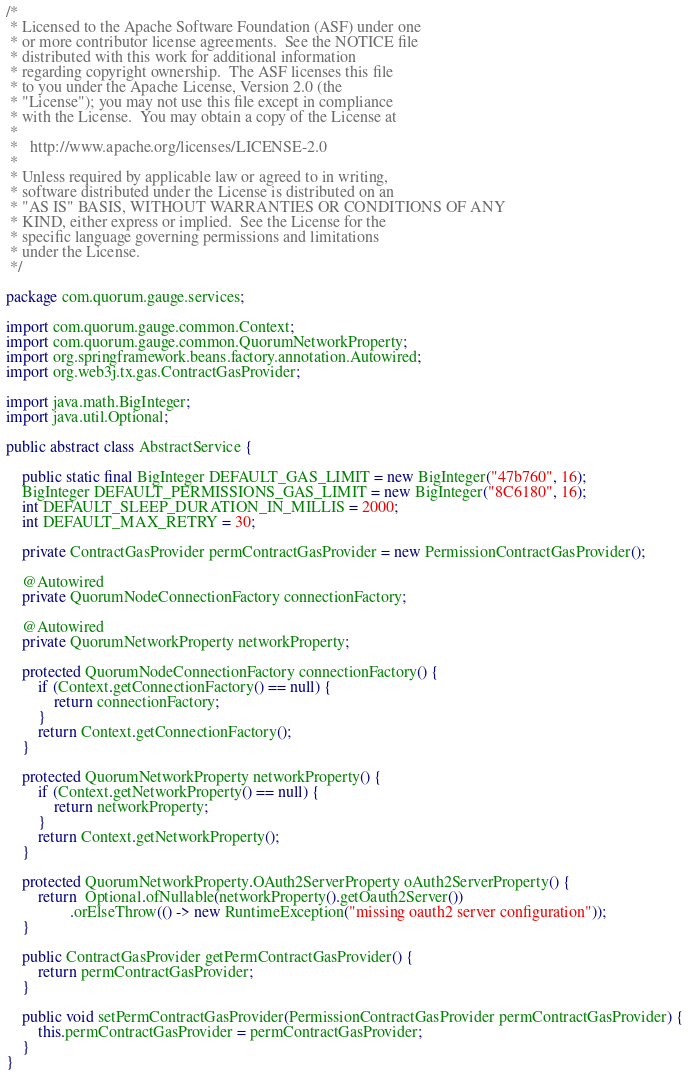<code> <loc_0><loc_0><loc_500><loc_500><_Java_>/*
 * Licensed to the Apache Software Foundation (ASF) under one
 * or more contributor license agreements.  See the NOTICE file
 * distributed with this work for additional information
 * regarding copyright ownership.  The ASF licenses this file
 * to you under the Apache License, Version 2.0 (the
 * "License"); you may not use this file except in compliance
 * with the License.  You may obtain a copy of the License at
 *
 *   http://www.apache.org/licenses/LICENSE-2.0
 *
 * Unless required by applicable law or agreed to in writing,
 * software distributed under the License is distributed on an
 * "AS IS" BASIS, WITHOUT WARRANTIES OR CONDITIONS OF ANY
 * KIND, either express or implied.  See the License for the
 * specific language governing permissions and limitations
 * under the License.
 */

package com.quorum.gauge.services;

import com.quorum.gauge.common.Context;
import com.quorum.gauge.common.QuorumNetworkProperty;
import org.springframework.beans.factory.annotation.Autowired;
import org.web3j.tx.gas.ContractGasProvider;

import java.math.BigInteger;
import java.util.Optional;

public abstract class AbstractService {

    public static final BigInteger DEFAULT_GAS_LIMIT = new BigInteger("47b760", 16);
    BigInteger DEFAULT_PERMISSIONS_GAS_LIMIT = new BigInteger("8C6180", 16);
    int DEFAULT_SLEEP_DURATION_IN_MILLIS = 2000;
    int DEFAULT_MAX_RETRY = 30;

    private ContractGasProvider permContractGasProvider = new PermissionContractGasProvider();

    @Autowired
    private QuorumNodeConnectionFactory connectionFactory;

    @Autowired
    private QuorumNetworkProperty networkProperty;

    protected QuorumNodeConnectionFactory connectionFactory() {
        if (Context.getConnectionFactory() == null) {
            return connectionFactory;
        }
        return Context.getConnectionFactory();
    }

    protected QuorumNetworkProperty networkProperty() {
        if (Context.getNetworkProperty() == null) {
            return networkProperty;
        }
        return Context.getNetworkProperty();
    }

    protected QuorumNetworkProperty.OAuth2ServerProperty oAuth2ServerProperty() {
        return  Optional.ofNullable(networkProperty().getOauth2Server())
                .orElseThrow(() -> new RuntimeException("missing oauth2 server configuration"));
    }

    public ContractGasProvider getPermContractGasProvider() {
        return permContractGasProvider;
    }

    public void setPermContractGasProvider(PermissionContractGasProvider permContractGasProvider) {
        this.permContractGasProvider = permContractGasProvider;
    }
}
</code> 